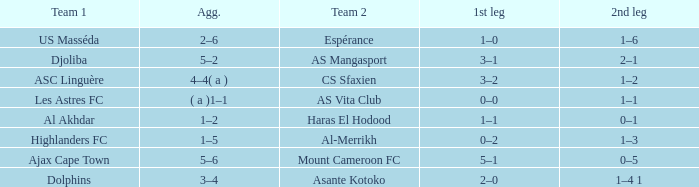What is the team 1 together with team 2 mount cameroon fc? Ajax Cape Town. 